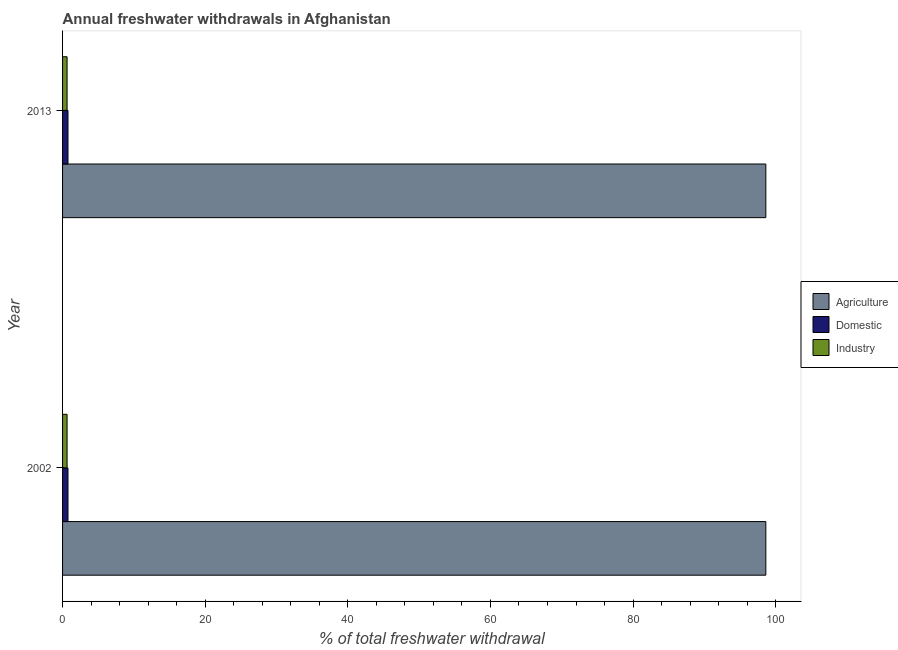How many groups of bars are there?
Ensure brevity in your answer.  2. Are the number of bars per tick equal to the number of legend labels?
Your response must be concise. Yes. How many bars are there on the 1st tick from the bottom?
Your answer should be compact. 3. What is the label of the 1st group of bars from the top?
Your answer should be very brief. 2013. What is the percentage of freshwater withdrawal for domestic purposes in 2013?
Offer a very short reply. 0.76. Across all years, what is the maximum percentage of freshwater withdrawal for industry?
Offer a terse response. 0.63. Across all years, what is the minimum percentage of freshwater withdrawal for domestic purposes?
Your answer should be compact. 0.76. In which year was the percentage of freshwater withdrawal for domestic purposes minimum?
Your answer should be very brief. 2002. What is the total percentage of freshwater withdrawal for domestic purposes in the graph?
Make the answer very short. 1.52. What is the difference between the percentage of freshwater withdrawal for domestic purposes in 2002 and the percentage of freshwater withdrawal for industry in 2013?
Make the answer very short. 0.13. What is the average percentage of freshwater withdrawal for domestic purposes per year?
Make the answer very short. 0.76. In the year 2013, what is the difference between the percentage of freshwater withdrawal for agriculture and percentage of freshwater withdrawal for industry?
Offer a very short reply. 97.99. Is the percentage of freshwater withdrawal for agriculture in 2002 less than that in 2013?
Provide a succinct answer. No. Is the difference between the percentage of freshwater withdrawal for agriculture in 2002 and 2013 greater than the difference between the percentage of freshwater withdrawal for industry in 2002 and 2013?
Provide a succinct answer. No. In how many years, is the percentage of freshwater withdrawal for domestic purposes greater than the average percentage of freshwater withdrawal for domestic purposes taken over all years?
Provide a short and direct response. 0. What does the 1st bar from the top in 2013 represents?
Your answer should be compact. Industry. What does the 1st bar from the bottom in 2013 represents?
Provide a succinct answer. Agriculture. Is it the case that in every year, the sum of the percentage of freshwater withdrawal for agriculture and percentage of freshwater withdrawal for domestic purposes is greater than the percentage of freshwater withdrawal for industry?
Ensure brevity in your answer.  Yes. How many bars are there?
Keep it short and to the point. 6. Are the values on the major ticks of X-axis written in scientific E-notation?
Keep it short and to the point. No. Does the graph contain any zero values?
Your answer should be very brief. No. Does the graph contain grids?
Offer a terse response. No. Where does the legend appear in the graph?
Make the answer very short. Center right. What is the title of the graph?
Offer a very short reply. Annual freshwater withdrawals in Afghanistan. Does "Tertiary education" appear as one of the legend labels in the graph?
Give a very brief answer. No. What is the label or title of the X-axis?
Give a very brief answer. % of total freshwater withdrawal. What is the label or title of the Y-axis?
Offer a terse response. Year. What is the % of total freshwater withdrawal in Agriculture in 2002?
Offer a terse response. 98.62. What is the % of total freshwater withdrawal in Domestic in 2002?
Make the answer very short. 0.76. What is the % of total freshwater withdrawal of Industry in 2002?
Your answer should be very brief. 0.63. What is the % of total freshwater withdrawal in Agriculture in 2013?
Your answer should be compact. 98.62. What is the % of total freshwater withdrawal in Domestic in 2013?
Offer a terse response. 0.76. What is the % of total freshwater withdrawal of Industry in 2013?
Give a very brief answer. 0.63. Across all years, what is the maximum % of total freshwater withdrawal of Agriculture?
Your response must be concise. 98.62. Across all years, what is the maximum % of total freshwater withdrawal in Domestic?
Ensure brevity in your answer.  0.76. Across all years, what is the maximum % of total freshwater withdrawal of Industry?
Your answer should be compact. 0.63. Across all years, what is the minimum % of total freshwater withdrawal of Agriculture?
Ensure brevity in your answer.  98.62. Across all years, what is the minimum % of total freshwater withdrawal in Domestic?
Make the answer very short. 0.76. Across all years, what is the minimum % of total freshwater withdrawal in Industry?
Your answer should be compact. 0.63. What is the total % of total freshwater withdrawal in Agriculture in the graph?
Offer a very short reply. 197.24. What is the total % of total freshwater withdrawal of Domestic in the graph?
Make the answer very short. 1.52. What is the total % of total freshwater withdrawal in Industry in the graph?
Make the answer very short. 1.27. What is the difference between the % of total freshwater withdrawal of Agriculture in 2002 and that in 2013?
Your response must be concise. 0. What is the difference between the % of total freshwater withdrawal of Agriculture in 2002 and the % of total freshwater withdrawal of Domestic in 2013?
Offer a very short reply. 97.86. What is the difference between the % of total freshwater withdrawal in Agriculture in 2002 and the % of total freshwater withdrawal in Industry in 2013?
Make the answer very short. 97.99. What is the difference between the % of total freshwater withdrawal in Domestic in 2002 and the % of total freshwater withdrawal in Industry in 2013?
Ensure brevity in your answer.  0.13. What is the average % of total freshwater withdrawal in Agriculture per year?
Your answer should be very brief. 98.62. What is the average % of total freshwater withdrawal of Domestic per year?
Your answer should be very brief. 0.76. What is the average % of total freshwater withdrawal of Industry per year?
Keep it short and to the point. 0.63. In the year 2002, what is the difference between the % of total freshwater withdrawal in Agriculture and % of total freshwater withdrawal in Domestic?
Give a very brief answer. 97.86. In the year 2002, what is the difference between the % of total freshwater withdrawal of Agriculture and % of total freshwater withdrawal of Industry?
Provide a short and direct response. 97.99. In the year 2002, what is the difference between the % of total freshwater withdrawal of Domestic and % of total freshwater withdrawal of Industry?
Your response must be concise. 0.13. In the year 2013, what is the difference between the % of total freshwater withdrawal in Agriculture and % of total freshwater withdrawal in Domestic?
Ensure brevity in your answer.  97.86. In the year 2013, what is the difference between the % of total freshwater withdrawal in Agriculture and % of total freshwater withdrawal in Industry?
Your response must be concise. 97.99. In the year 2013, what is the difference between the % of total freshwater withdrawal of Domestic and % of total freshwater withdrawal of Industry?
Provide a short and direct response. 0.13. What is the ratio of the % of total freshwater withdrawal in Domestic in 2002 to that in 2013?
Offer a terse response. 1. What is the ratio of the % of total freshwater withdrawal of Industry in 2002 to that in 2013?
Keep it short and to the point. 1. What is the difference between the highest and the second highest % of total freshwater withdrawal of Agriculture?
Keep it short and to the point. 0. What is the difference between the highest and the second highest % of total freshwater withdrawal in Domestic?
Your answer should be compact. 0. What is the difference between the highest and the second highest % of total freshwater withdrawal of Industry?
Provide a short and direct response. 0. What is the difference between the highest and the lowest % of total freshwater withdrawal in Domestic?
Your response must be concise. 0. 